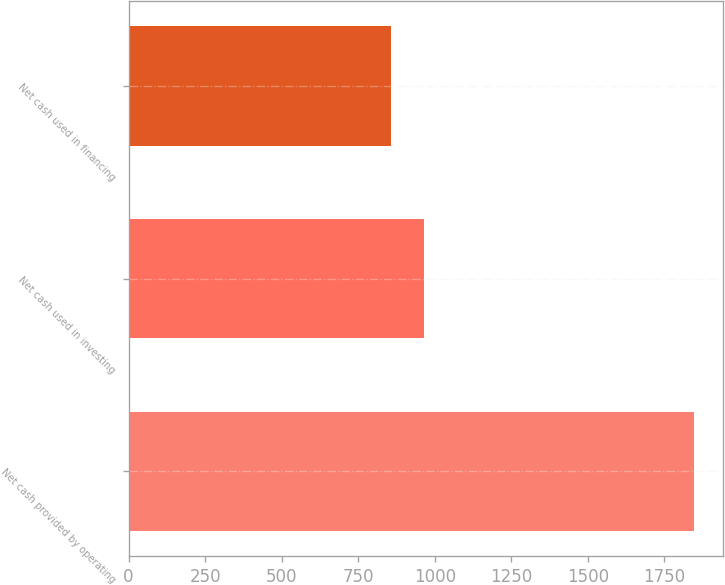Convert chart. <chart><loc_0><loc_0><loc_500><loc_500><bar_chart><fcel>Net cash provided by operating<fcel>Net cash used in investing<fcel>Net cash used in financing<nl><fcel>1847.8<fcel>964.5<fcel>856.8<nl></chart> 